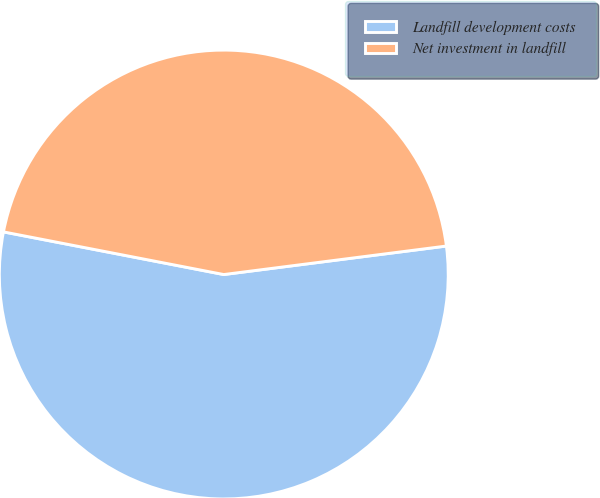Convert chart to OTSL. <chart><loc_0><loc_0><loc_500><loc_500><pie_chart><fcel>Landfill development costs<fcel>Net investment in landfill<nl><fcel>55.07%<fcel>44.93%<nl></chart> 